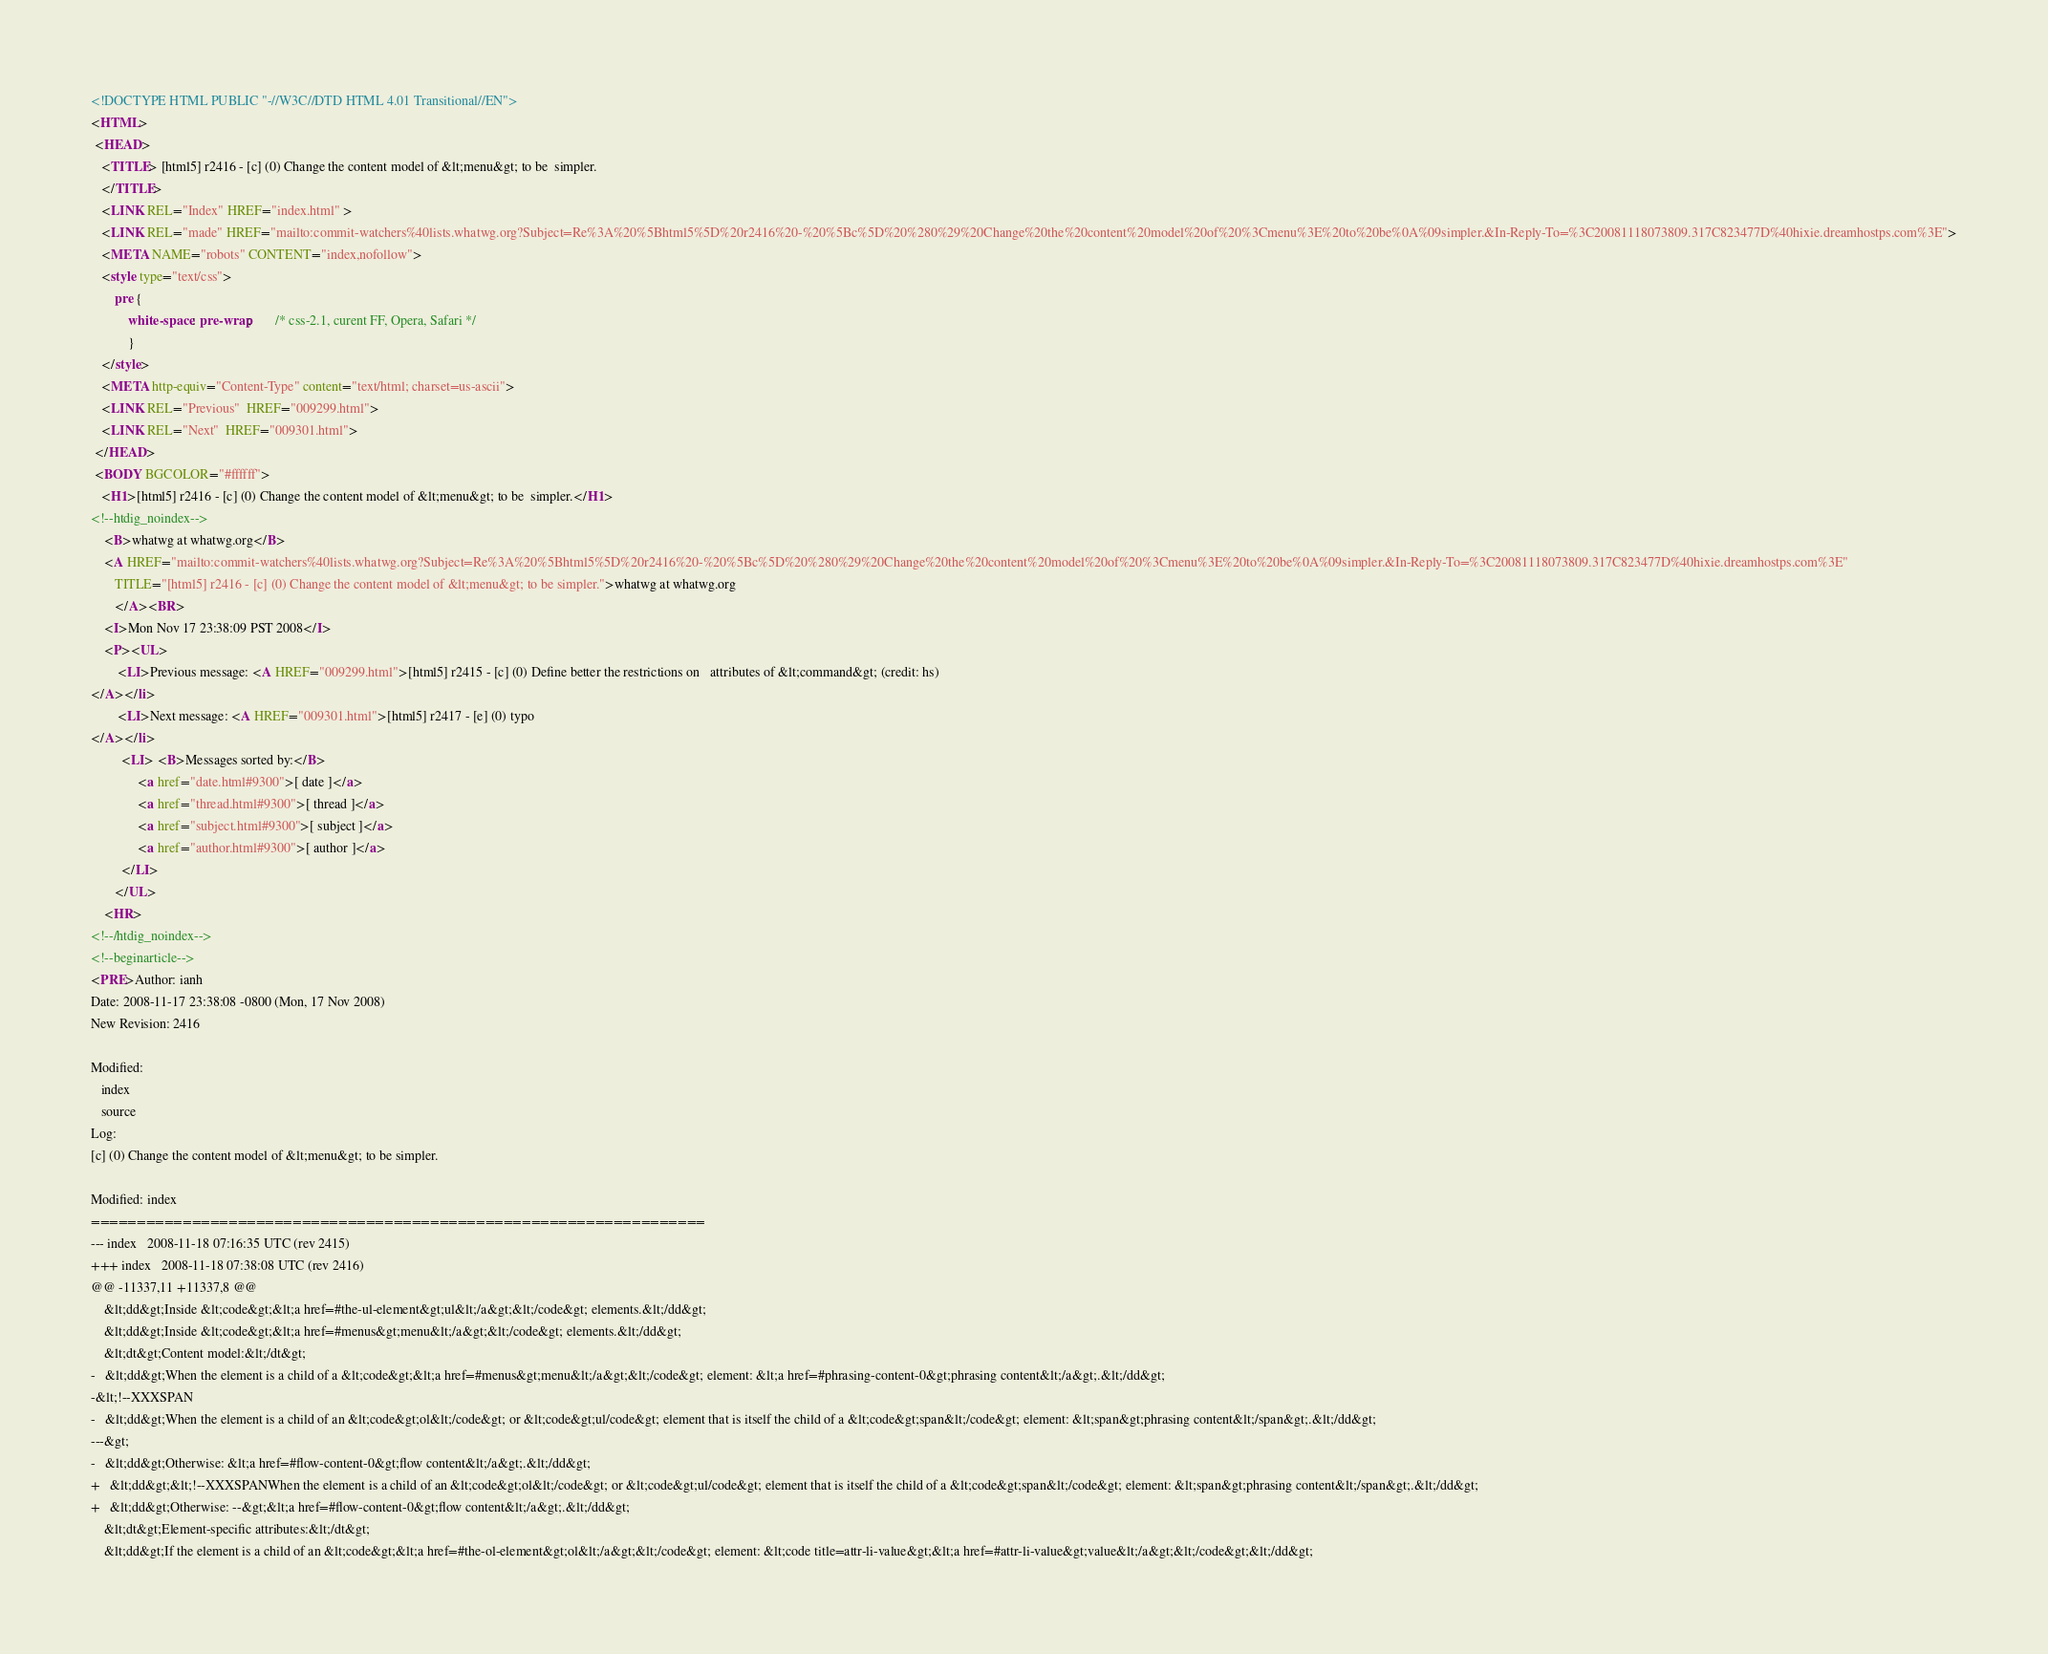Convert code to text. <code><loc_0><loc_0><loc_500><loc_500><_HTML_><!DOCTYPE HTML PUBLIC "-//W3C//DTD HTML 4.01 Transitional//EN">
<HTML>
 <HEAD>
   <TITLE> [html5] r2416 - [c] (0) Change the content model of &lt;menu&gt; to be	simpler.
   </TITLE>
   <LINK REL="Index" HREF="index.html" >
   <LINK REL="made" HREF="mailto:commit-watchers%40lists.whatwg.org?Subject=Re%3A%20%5Bhtml5%5D%20r2416%20-%20%5Bc%5D%20%280%29%20Change%20the%20content%20model%20of%20%3Cmenu%3E%20to%20be%0A%09simpler.&In-Reply-To=%3C20081118073809.317C823477D%40hixie.dreamhostps.com%3E">
   <META NAME="robots" CONTENT="index,nofollow">
   <style type="text/css">
       pre {
           white-space: pre-wrap;       /* css-2.1, curent FF, Opera, Safari */
           }
   </style>
   <META http-equiv="Content-Type" content="text/html; charset=us-ascii">
   <LINK REL="Previous"  HREF="009299.html">
   <LINK REL="Next"  HREF="009301.html">
 </HEAD>
 <BODY BGCOLOR="#ffffff">
   <H1>[html5] r2416 - [c] (0) Change the content model of &lt;menu&gt; to be	simpler.</H1>
<!--htdig_noindex-->
    <B>whatwg at whatwg.org</B> 
    <A HREF="mailto:commit-watchers%40lists.whatwg.org?Subject=Re%3A%20%5Bhtml5%5D%20r2416%20-%20%5Bc%5D%20%280%29%20Change%20the%20content%20model%20of%20%3Cmenu%3E%20to%20be%0A%09simpler.&In-Reply-To=%3C20081118073809.317C823477D%40hixie.dreamhostps.com%3E"
       TITLE="[html5] r2416 - [c] (0) Change the content model of &lt;menu&gt; to be	simpler.">whatwg at whatwg.org
       </A><BR>
    <I>Mon Nov 17 23:38:09 PST 2008</I>
    <P><UL>
        <LI>Previous message: <A HREF="009299.html">[html5] r2415 - [c] (0) Define better the restrictions on	attributes of &lt;command&gt; (credit: hs)
</A></li>
        <LI>Next message: <A HREF="009301.html">[html5] r2417 - [e] (0) typo
</A></li>
         <LI> <B>Messages sorted by:</B> 
              <a href="date.html#9300">[ date ]</a>
              <a href="thread.html#9300">[ thread ]</a>
              <a href="subject.html#9300">[ subject ]</a>
              <a href="author.html#9300">[ author ]</a>
         </LI>
       </UL>
    <HR>  
<!--/htdig_noindex-->
<!--beginarticle-->
<PRE>Author: ianh
Date: 2008-11-17 23:38:08 -0800 (Mon, 17 Nov 2008)
New Revision: 2416

Modified:
   index
   source
Log:
[c] (0) Change the content model of &lt;menu&gt; to be simpler.

Modified: index
===================================================================
--- index	2008-11-18 07:16:35 UTC (rev 2415)
+++ index	2008-11-18 07:38:08 UTC (rev 2416)
@@ -11337,11 +11337,8 @@
    &lt;dd&gt;Inside &lt;code&gt;&lt;a href=#the-ul-element&gt;ul&lt;/a&gt;&lt;/code&gt; elements.&lt;/dd&gt;
    &lt;dd&gt;Inside &lt;code&gt;&lt;a href=#menus&gt;menu&lt;/a&gt;&lt;/code&gt; elements.&lt;/dd&gt;
    &lt;dt&gt;Content model:&lt;/dt&gt;
-   &lt;dd&gt;When the element is a child of a &lt;code&gt;&lt;a href=#menus&gt;menu&lt;/a&gt;&lt;/code&gt; element: &lt;a href=#phrasing-content-0&gt;phrasing content&lt;/a&gt;.&lt;/dd&gt;
-&lt;!--XXXSPAN
-   &lt;dd&gt;When the element is a child of an &lt;code&gt;ol&lt;/code&gt; or &lt;code&gt;ul/code&gt; element that is itself the child of a &lt;code&gt;span&lt;/code&gt; element: &lt;span&gt;phrasing content&lt;/span&gt;.&lt;/dd&gt;
---&gt;
-   &lt;dd&gt;Otherwise: &lt;a href=#flow-content-0&gt;flow content&lt;/a&gt;.&lt;/dd&gt;
+   &lt;dd&gt;&lt;!--XXXSPANWhen the element is a child of an &lt;code&gt;ol&lt;/code&gt; or &lt;code&gt;ul/code&gt; element that is itself the child of a &lt;code&gt;span&lt;/code&gt; element: &lt;span&gt;phrasing content&lt;/span&gt;.&lt;/dd&gt;
+   &lt;dd&gt;Otherwise: --&gt;&lt;a href=#flow-content-0&gt;flow content&lt;/a&gt;.&lt;/dd&gt;
    &lt;dt&gt;Element-specific attributes:&lt;/dt&gt;
    &lt;dd&gt;If the element is a child of an &lt;code&gt;&lt;a href=#the-ol-element&gt;ol&lt;/a&gt;&lt;/code&gt; element: &lt;code title=attr-li-value&gt;&lt;a href=#attr-li-value&gt;value&lt;/a&gt;&lt;/code&gt;&lt;/dd&gt;</code> 